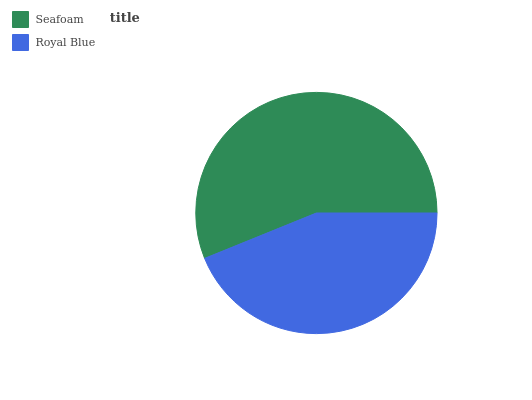Is Royal Blue the minimum?
Answer yes or no. Yes. Is Seafoam the maximum?
Answer yes or no. Yes. Is Royal Blue the maximum?
Answer yes or no. No. Is Seafoam greater than Royal Blue?
Answer yes or no. Yes. Is Royal Blue less than Seafoam?
Answer yes or no. Yes. Is Royal Blue greater than Seafoam?
Answer yes or no. No. Is Seafoam less than Royal Blue?
Answer yes or no. No. Is Seafoam the high median?
Answer yes or no. Yes. Is Royal Blue the low median?
Answer yes or no. Yes. Is Royal Blue the high median?
Answer yes or no. No. Is Seafoam the low median?
Answer yes or no. No. 